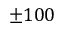<formula> <loc_0><loc_0><loc_500><loc_500>\pm 1 0 0</formula> 